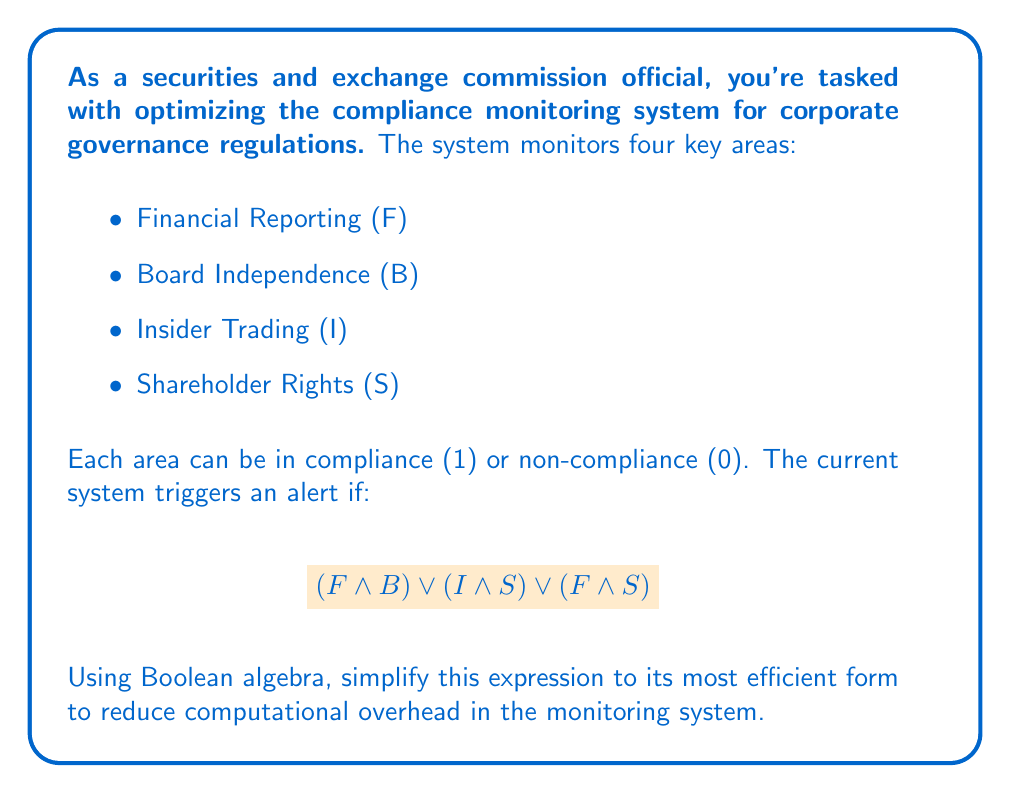Give your solution to this math problem. Let's simplify the given Boolean expression step by step:

1) Start with the original expression:
   $$(F \land B) \lor (I \land S) \lor (F \land S)$$

2) Apply the distributive law to factor out $S$:
   $$(F \land B) \lor (S \land (I \lor F))$$

3) Apply the distributive law again to factor out $F$:
   $$F \land (B \lor S) \lor (S \land I)$$

4) Use the associative law to rearrange terms:
   $$(F \land (B \lor S)) \lor (S \land I)$$

5) Apply the distributive law one more time:
   $$F \land B \lor F \land S \lor S \land I$$

This is the most simplified form using Boolean algebra. It reduces the number of logical operations from 5 in the original expression to 4 in the optimized version, potentially improving the efficiency of the compliance monitoring system.
Answer: $$F \land B \lor F \land S \lor S \land I$$ 